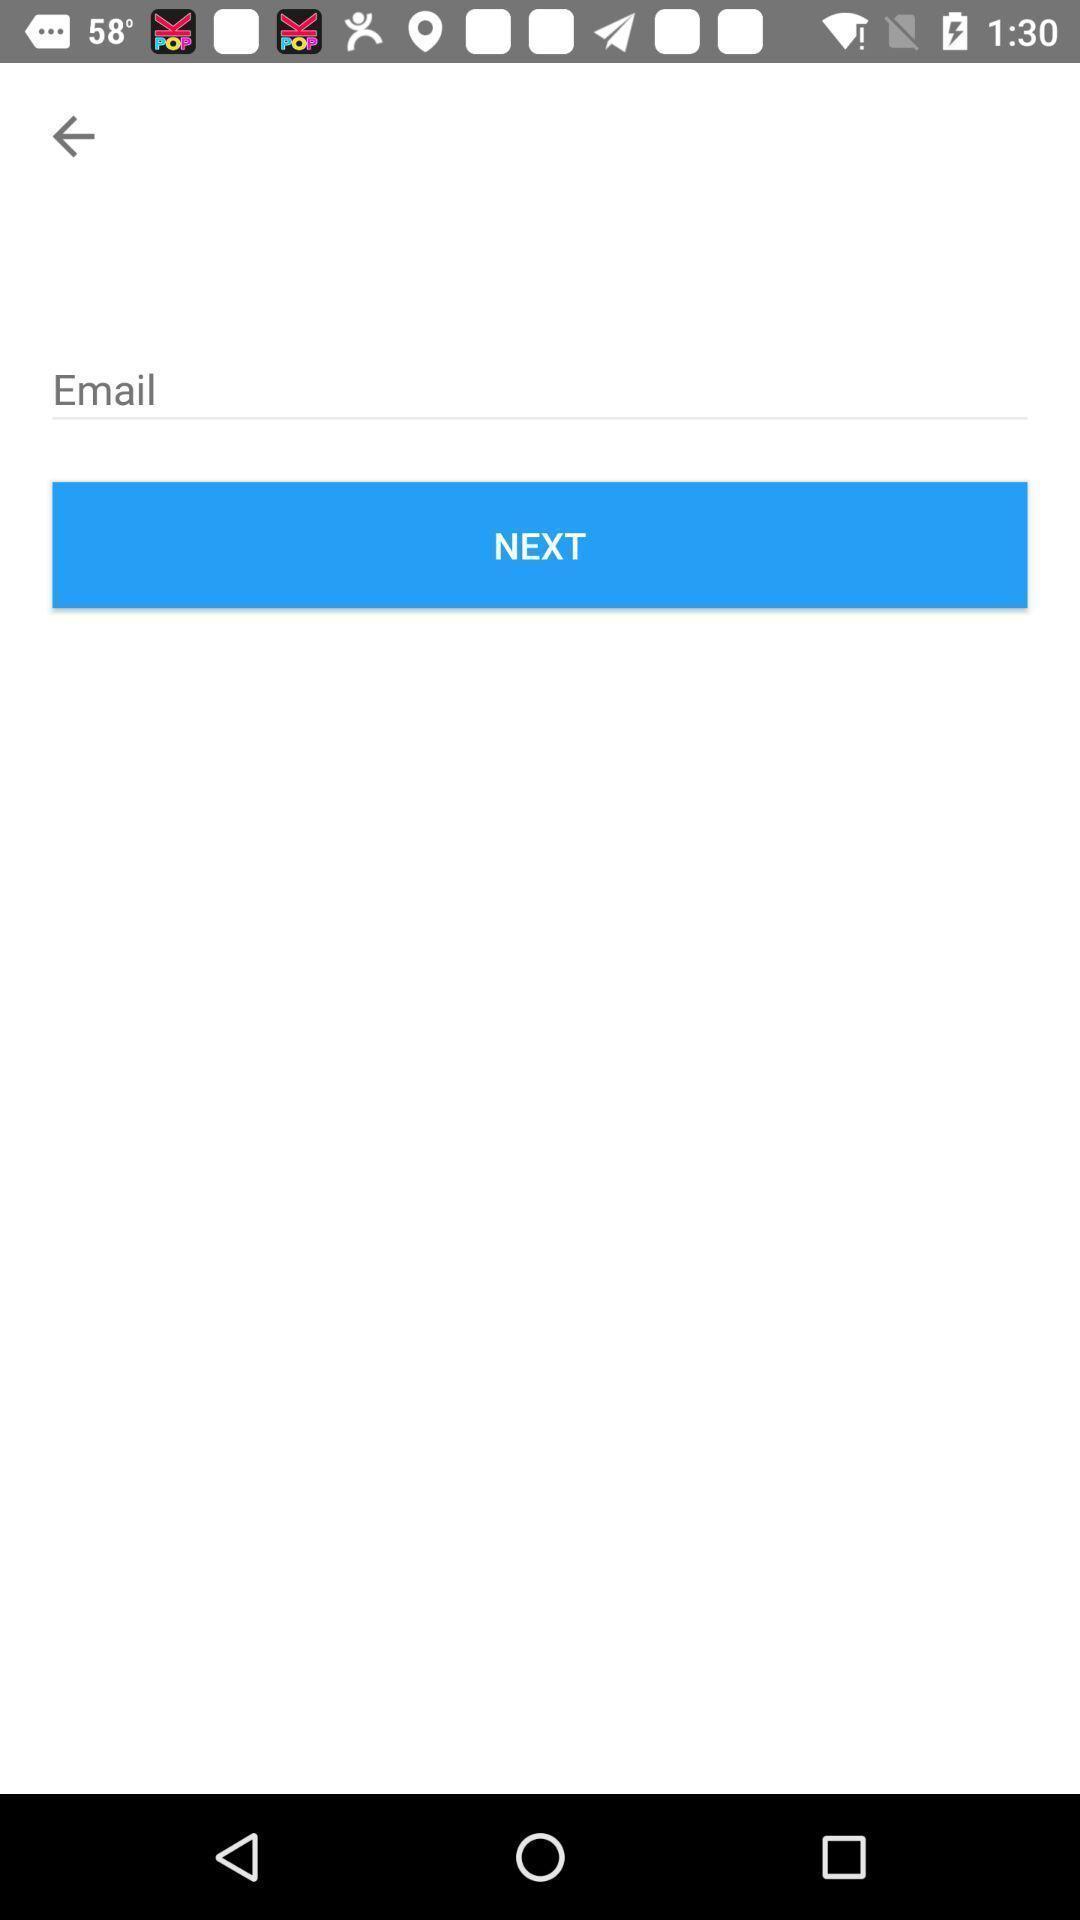Give me a summary of this screen capture. Screen to enter mail details. 